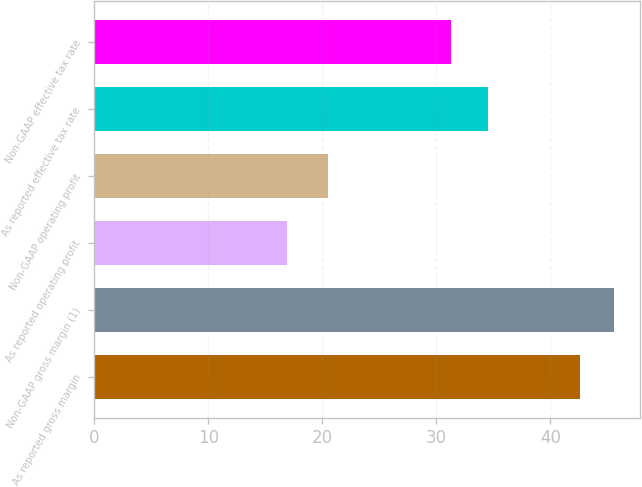<chart> <loc_0><loc_0><loc_500><loc_500><bar_chart><fcel>As reported gross margin<fcel>Non-GAAP gross margin (1)<fcel>As reported operating profit<fcel>Non-GAAP operating profit<fcel>As reported effective tax rate<fcel>Non-GAAP effective tax rate<nl><fcel>42.6<fcel>45.6<fcel>16.9<fcel>20.5<fcel>34.5<fcel>31.3<nl></chart> 